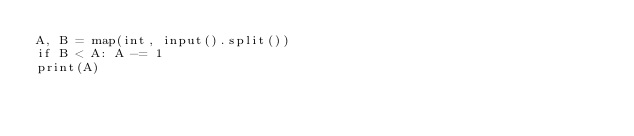Convert code to text. <code><loc_0><loc_0><loc_500><loc_500><_Python_>A, B = map(int, input().split())
if B < A: A -= 1
print(A)</code> 